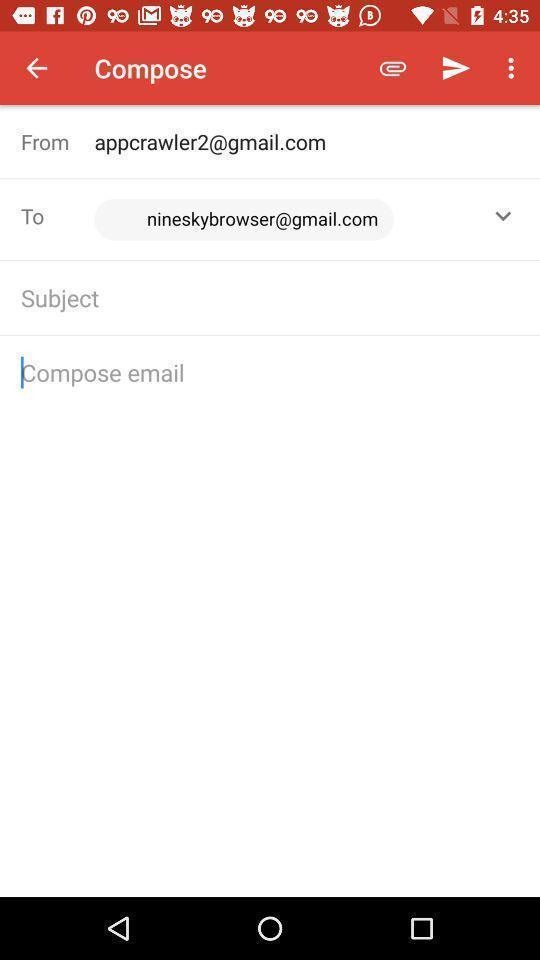Provide a description of this screenshot. Page displaying with new mail to compose. 